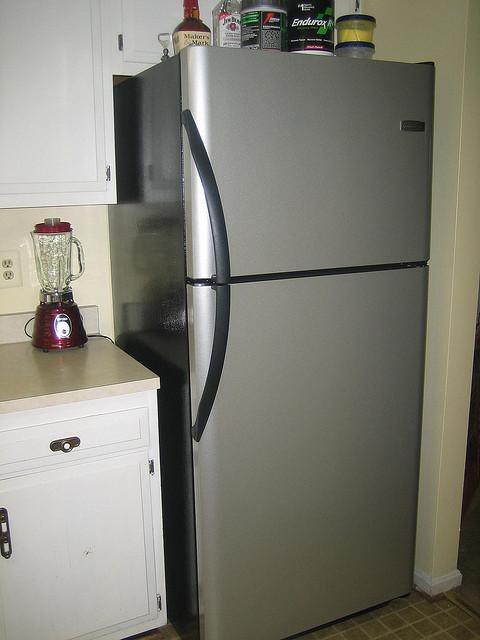How many bottles are visible?
Give a very brief answer. 2. 